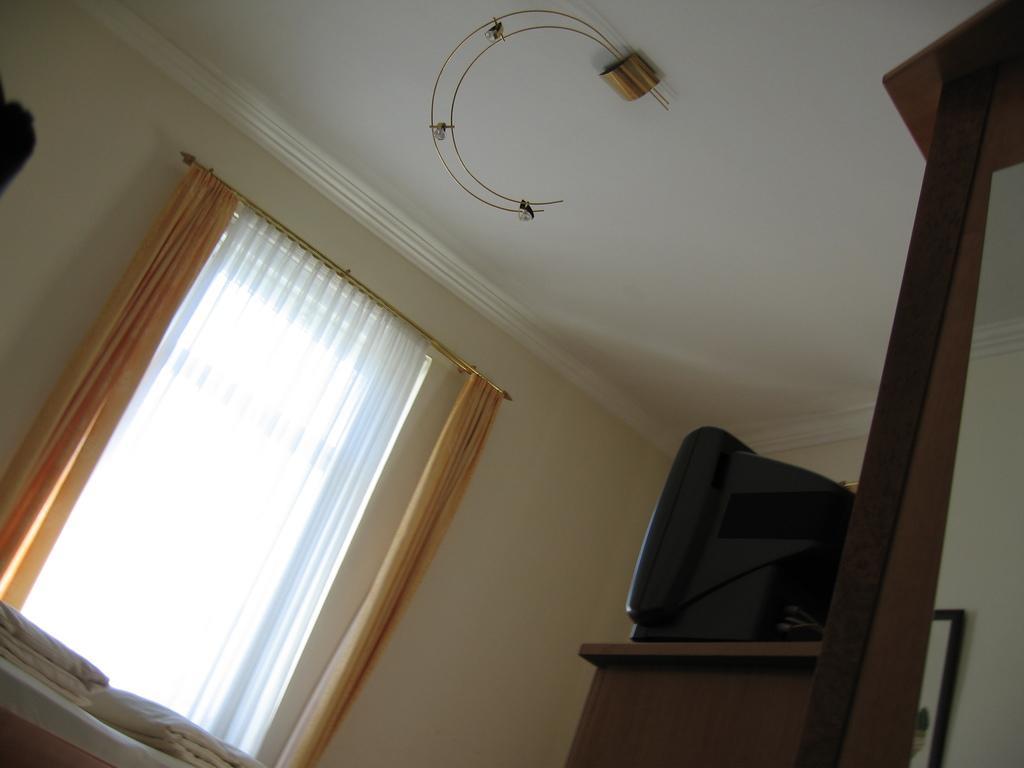In one or two sentences, can you explain what this image depicts? This is clicked inside a room, there is a window with curtains on the wall, on the right side there is a tv on the table, over the ceiling there are two metal strings hanging. 